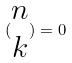<formula> <loc_0><loc_0><loc_500><loc_500>( \begin{matrix} n \\ k \end{matrix} ) = 0</formula> 